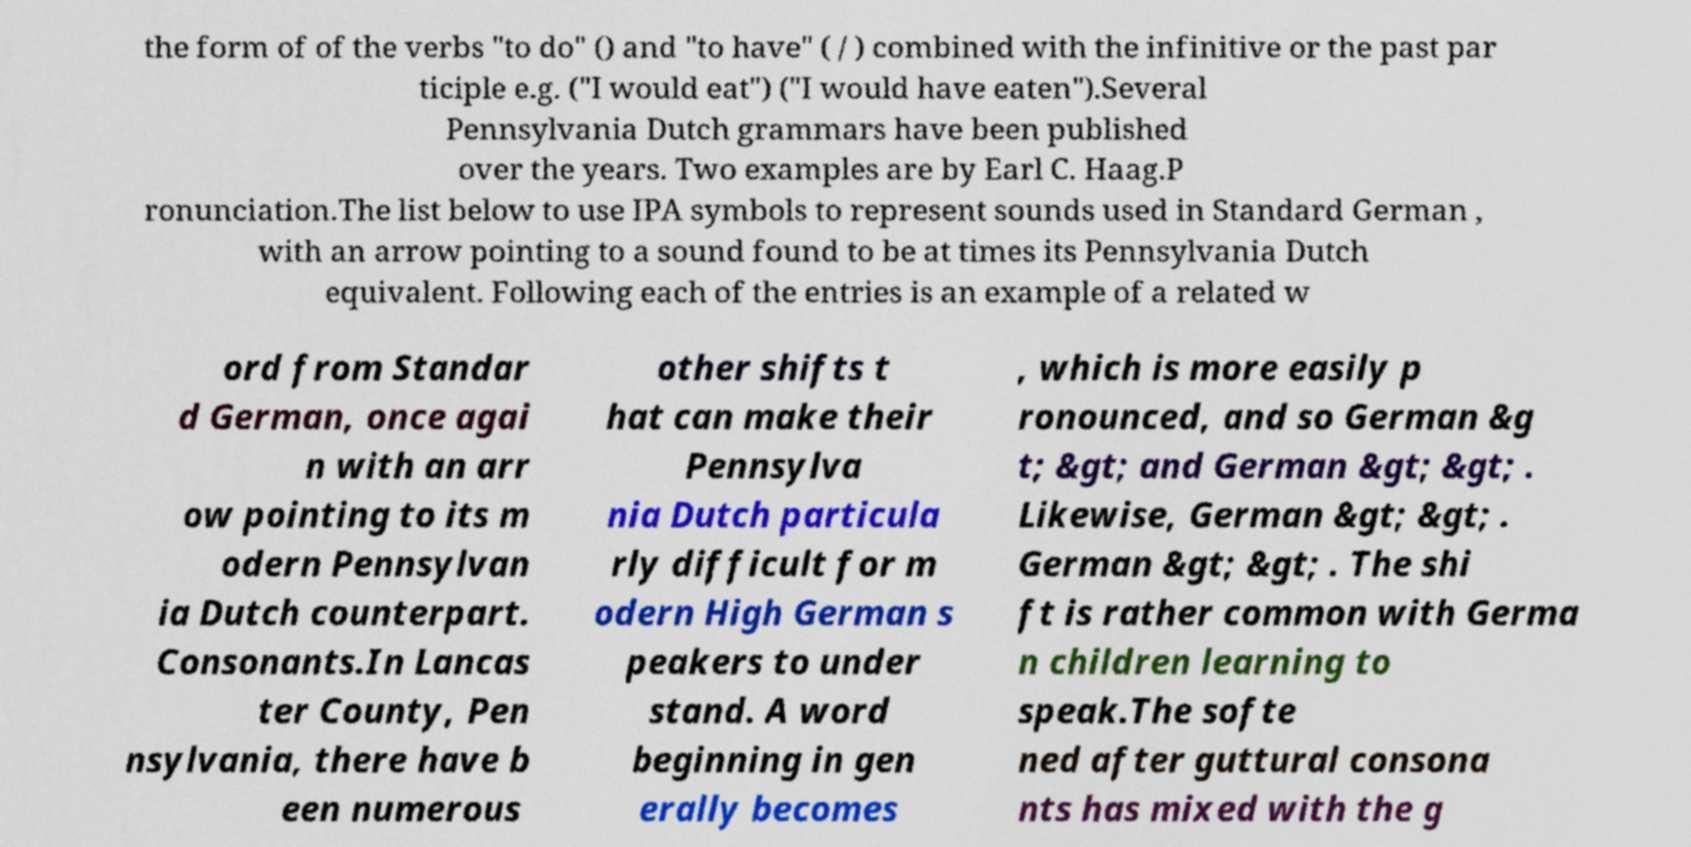I need the written content from this picture converted into text. Can you do that? the form of of the verbs "to do" () and "to have" ( / ) combined with the infinitive or the past par ticiple e.g. ("I would eat") ("I would have eaten").Several Pennsylvania Dutch grammars have been published over the years. Two examples are by Earl C. Haag.P ronunciation.The list below to use IPA symbols to represent sounds used in Standard German , with an arrow pointing to a sound found to be at times its Pennsylvania Dutch equivalent. Following each of the entries is an example of a related w ord from Standar d German, once agai n with an arr ow pointing to its m odern Pennsylvan ia Dutch counterpart. Consonants.In Lancas ter County, Pen nsylvania, there have b een numerous other shifts t hat can make their Pennsylva nia Dutch particula rly difficult for m odern High German s peakers to under stand. A word beginning in gen erally becomes , which is more easily p ronounced, and so German &g t; &gt; and German &gt; &gt; . Likewise, German &gt; &gt; . German &gt; &gt; . The shi ft is rather common with Germa n children learning to speak.The softe ned after guttural consona nts has mixed with the g 